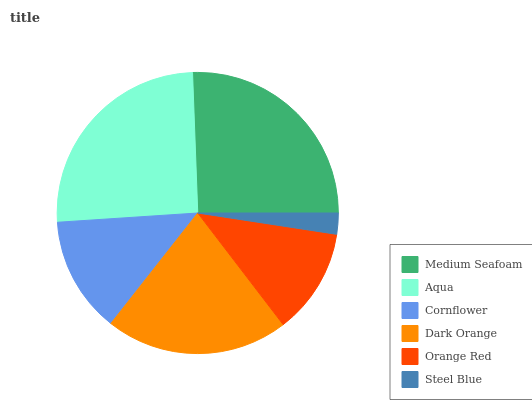Is Steel Blue the minimum?
Answer yes or no. Yes. Is Medium Seafoam the maximum?
Answer yes or no. Yes. Is Aqua the minimum?
Answer yes or no. No. Is Aqua the maximum?
Answer yes or no. No. Is Medium Seafoam greater than Aqua?
Answer yes or no. Yes. Is Aqua less than Medium Seafoam?
Answer yes or no. Yes. Is Aqua greater than Medium Seafoam?
Answer yes or no. No. Is Medium Seafoam less than Aqua?
Answer yes or no. No. Is Dark Orange the high median?
Answer yes or no. Yes. Is Cornflower the low median?
Answer yes or no. Yes. Is Cornflower the high median?
Answer yes or no. No. Is Steel Blue the low median?
Answer yes or no. No. 